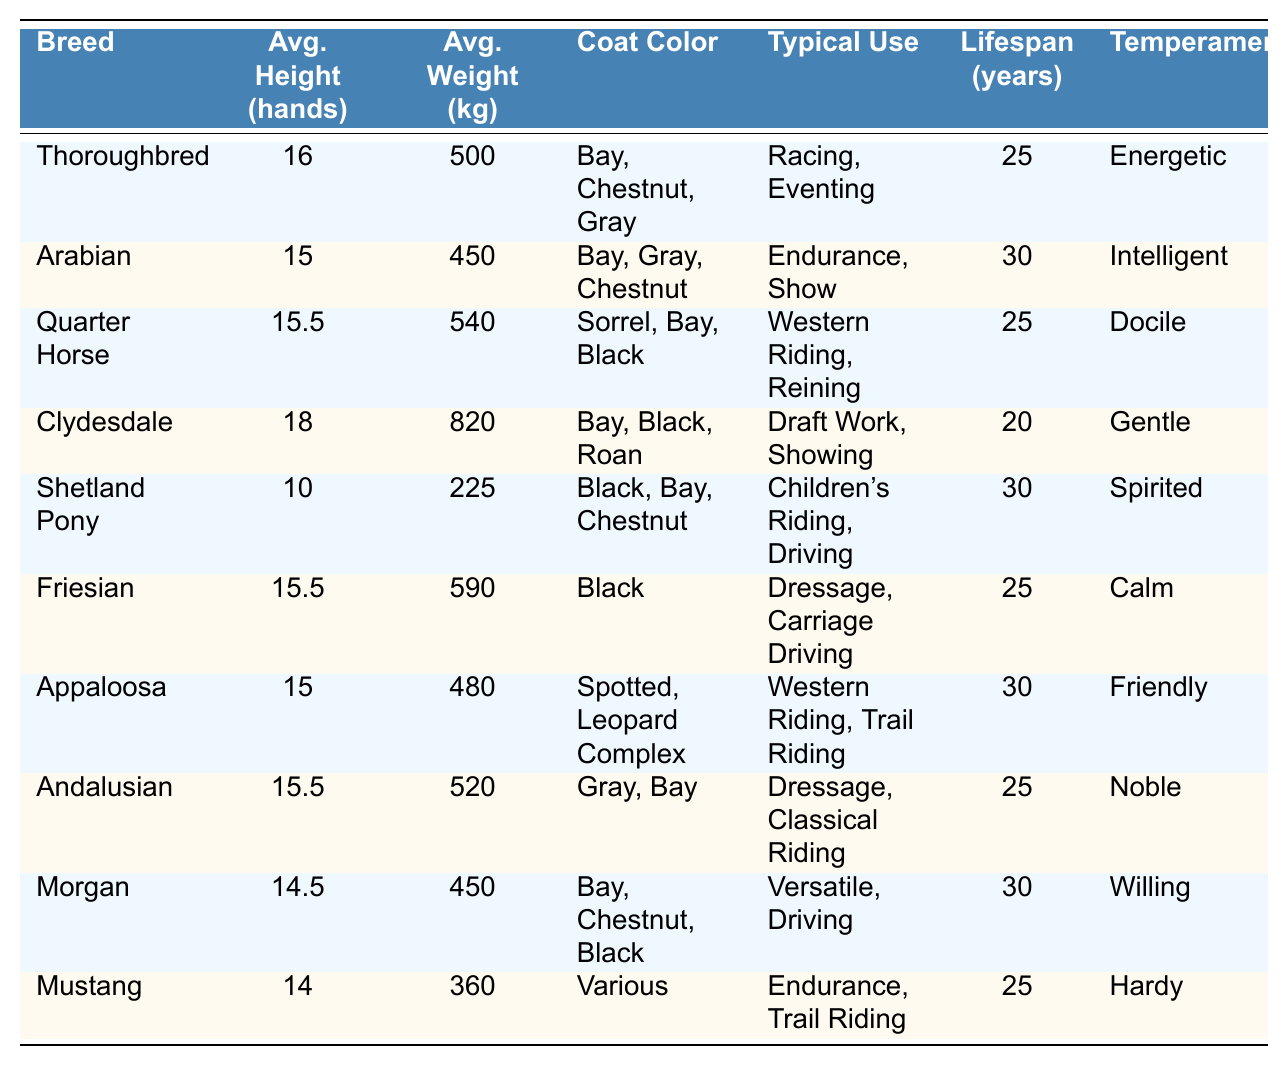What is the average height of a Thoroughbred horse? The table shows that the average height of a Thoroughbred horse is listed as 16 hands.
Answer: 16 hands Which horse breed has the highest average weight? By comparing the average weights in the table, the Clydesdale breed has the highest average weight at 820 kg.
Answer: Clydesdale What is the typical use of an Arabian horse? The table indicates that Arabian horses are typically used for endurance and show.
Answer: Endurance, Show Is the lifespan of a Shetland Pony longer than that of a Clydesdale? The table states that Shetland Ponies can live up to 30 years, while Clydesdales have a lifespan of 20 years; therefore, the lifespan of a Shetland Pony is indeed longer than that of a Clydesdale.
Answer: Yes How many horse breeds have an average height greater than 15 hands? The breeds with an average height greater than 15 hands are Thoroughbred (16), Quarter Horse (15.5), Clydesdale (18), and Friesian (15.5). Counting these yields 4 breeds.
Answer: 4 Which horse breed has the calmest temperament according to the table? According to the data in the table, the Friesian breed has the temperament rated as calm.
Answer: Friesian If we consider the average lifespan of all the horses, what is the median lifespan? Listing the lifespans in ascending order gives us: 20, 25, 25, 25, 30, 30, 30, 30, 30. Since there are 10 values, we take the average of the 5th and 6th (both are 30 years), resulting in a median lifespan of 27.5 years.
Answer: 27.5 years How does the average weight of an Arabian horse compare to that of a Mustang? The average weight of an Arabian horse is 450 kg, while that of a Mustang is 360 kg. This shows that the Arabian horse is heavier by 90 kg.
Answer: 90 kg heavier Is it true that all horses listed have an average lifespan of 25 years or more? Examining the table, the Clydesdale has a lifespan of 20 years, so this statement is false.
Answer: No Which two horse breeds are primarily used for Western riding according to the data? The table reveals that both the Quarter Horse and Appaloosa are typically used for Western Riding.
Answer: Quarter Horse and Appaloosa 